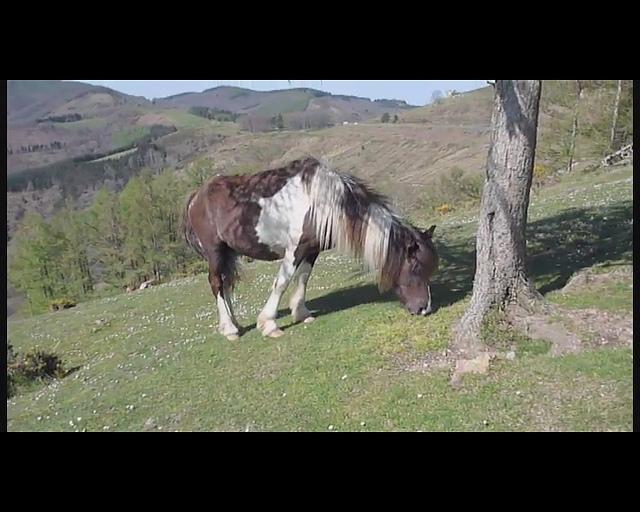How many colors is the horse?
Give a very brief answer. 2. How many horses are in the picture?
Give a very brief answer. 1. 